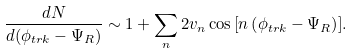<formula> <loc_0><loc_0><loc_500><loc_500>\frac { d N } { d ( \phi _ { t r k } - \Psi _ { R } ) } \sim 1 + \sum _ { n } 2 v _ { n } \cos { \left [ n \left ( \phi _ { t r k } - \Psi _ { R } \right ) \right ] } .</formula> 